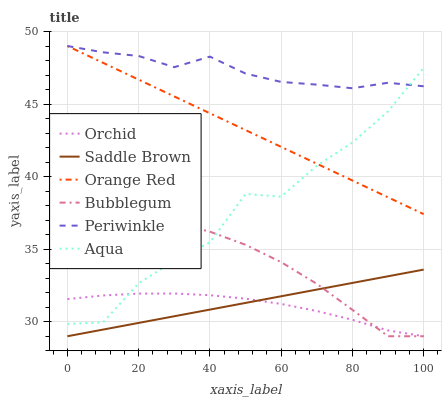Does Orchid have the minimum area under the curve?
Answer yes or no. Yes. Does Periwinkle have the maximum area under the curve?
Answer yes or no. Yes. Does Bubblegum have the minimum area under the curve?
Answer yes or no. No. Does Bubblegum have the maximum area under the curve?
Answer yes or no. No. Is Orange Red the smoothest?
Answer yes or no. Yes. Is Aqua the roughest?
Answer yes or no. Yes. Is Bubblegum the smoothest?
Answer yes or no. No. Is Bubblegum the roughest?
Answer yes or no. No. Does Bubblegum have the lowest value?
Answer yes or no. Yes. Does Orange Red have the lowest value?
Answer yes or no. No. Does Periwinkle have the highest value?
Answer yes or no. Yes. Does Bubblegum have the highest value?
Answer yes or no. No. Is Saddle Brown less than Orange Red?
Answer yes or no. Yes. Is Aqua greater than Saddle Brown?
Answer yes or no. Yes. Does Bubblegum intersect Aqua?
Answer yes or no. Yes. Is Bubblegum less than Aqua?
Answer yes or no. No. Is Bubblegum greater than Aqua?
Answer yes or no. No. Does Saddle Brown intersect Orange Red?
Answer yes or no. No. 